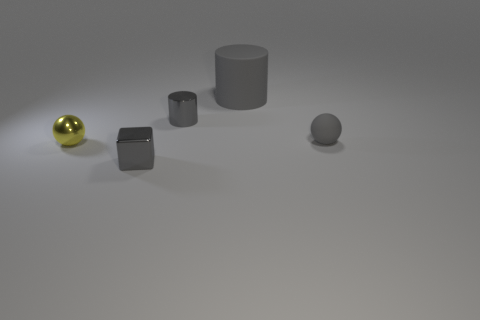Subtract all gray cylinders. How many were subtracted if there are1gray cylinders left? 1 Add 4 tiny green cubes. How many objects exist? 9 Subtract all cylinders. How many objects are left? 3 Subtract 1 blocks. How many blocks are left? 0 Subtract 0 yellow blocks. How many objects are left? 5 Subtract all purple spheres. Subtract all brown cylinders. How many spheres are left? 2 Subtract all red cylinders. How many yellow spheres are left? 1 Subtract all tiny purple cubes. Subtract all gray metallic cylinders. How many objects are left? 4 Add 1 gray matte things. How many gray matte things are left? 3 Add 5 small purple rubber things. How many small purple rubber things exist? 5 